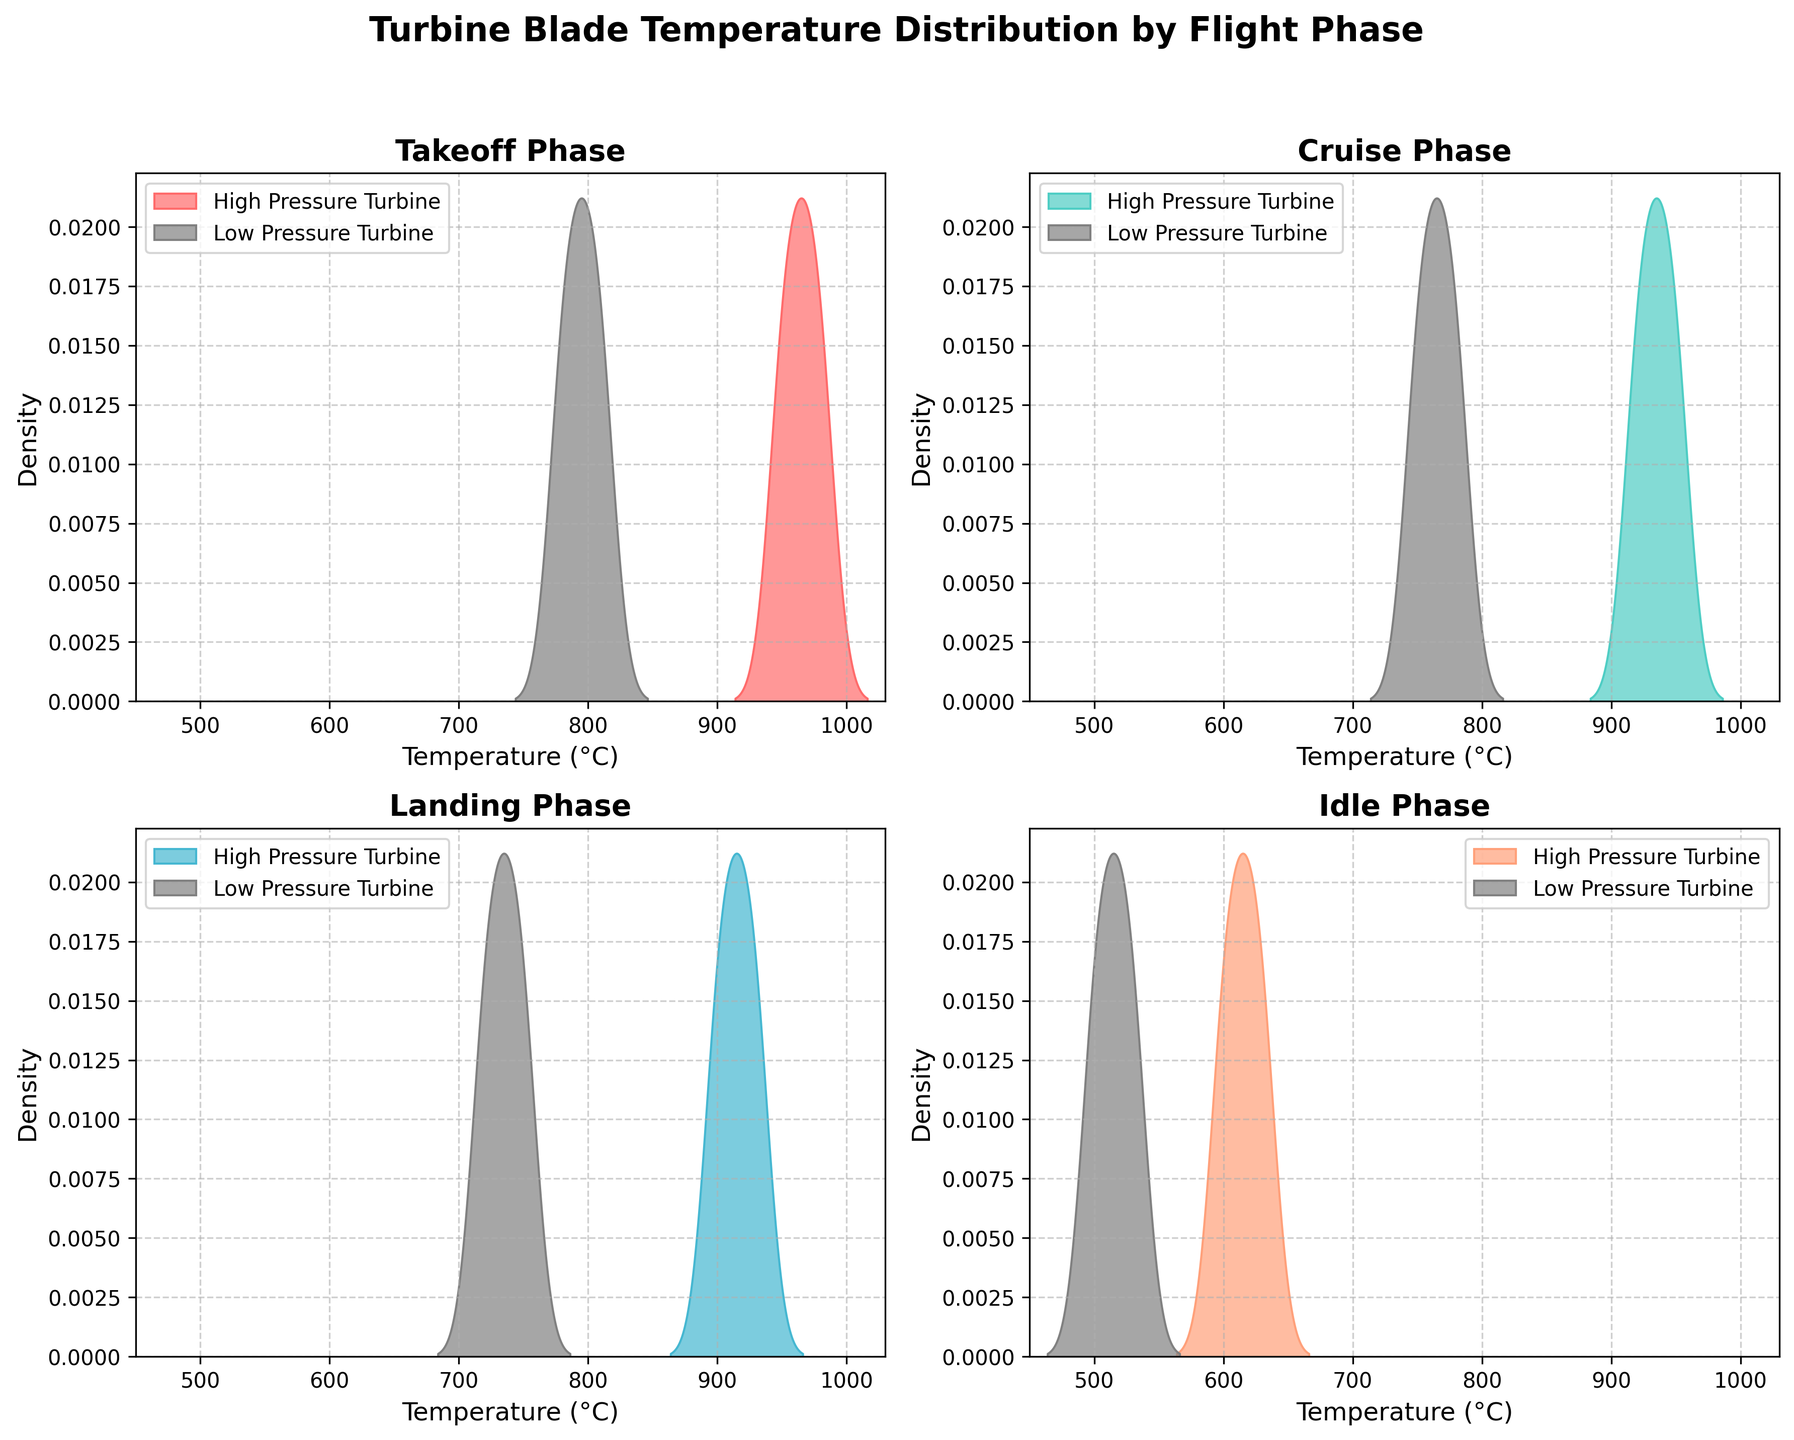what is the title of the figure? The title can be found at the top of the figure in bold font, which reads "Turbine Blade Temperature Distribution by Flight Phase".
Answer: Turbine Blade Temperature Distribution by Flight Phase How many density plots are shown in total? There are 4 subplots, one for each flight phase (Takeoff, Cruise, Landing, Idle), and each subplot contains 2 density plots for high-pressure and low-pressure turbine blades.
Answer: 8 What is the color used to represent high-pressure turbine blades during the cruise phase? In the cruise phase subplot, the high-pressure turbine blades are represented by the color that corresponds to "#4ECDC4".
Answer: A shade of turquoise Which flight phase shows the highest density peak for high-pressure turbine blades? By observing the peaks of the density plots for high-pressure turbine blades across all phases, the Takeoff phase has the highest density peak reaching close to 980°C.
Answer: Takeoff Compare the distributions of low-pressure turbine blade temperatures between the cruise and landing phases. Which phase exhibits wider temperature variability? Comparing the spread of the density curves for low-pressure turbine blades, the Cruise phase's density plot is wider, indicating more variability in temperature compared to the Landing phase.
Answer: Cruise During the idle phase, what is the approximate temperature range for the high-pressure turbine blade density plot? The density plot for high-pressure turbine blades in the Idle phase extends from around 600°C to 630°C.
Answer: 600°C to 630°C Between which two flight phases is the temperature range for high-pressure turbine blades most similar? By assessing the ranges of the high-pressure turbine blade temperature density plots, the phases 'Cruise' and 'Landing' both range approximately from 900°C to 950°C.
Answer: Cruise and Landing Which turbine blade type tends to have the lower temperature range, high-pressure or low-pressure, especially noticeable during the takeoff phase? Observing the density plots for the takeoff phase, the low-pressure turbine blades exhibit a temperature range from 780°C to 810°C, which is significantly lower than the high-pressure turbine blades.
Answer: Low-pressure Which flight phase indicates the coolest average temperature for both turbine blade types combined? The average temperature for both high and low-pressure turbine blades in the Idle phase shows the coolest distribution, centered below 600°C for low-pressure and around 615°C for high-pressure.
Answer: Idle What are the axes labels for the subplots, and what do they represent? The x-axis is labeled 'Temperature (°C)', representing the temperature in degrees Celsius, while the y-axis is labeled 'Density', representing the probability density of the temperature values.
Answer: Temperature (°C) and Density 